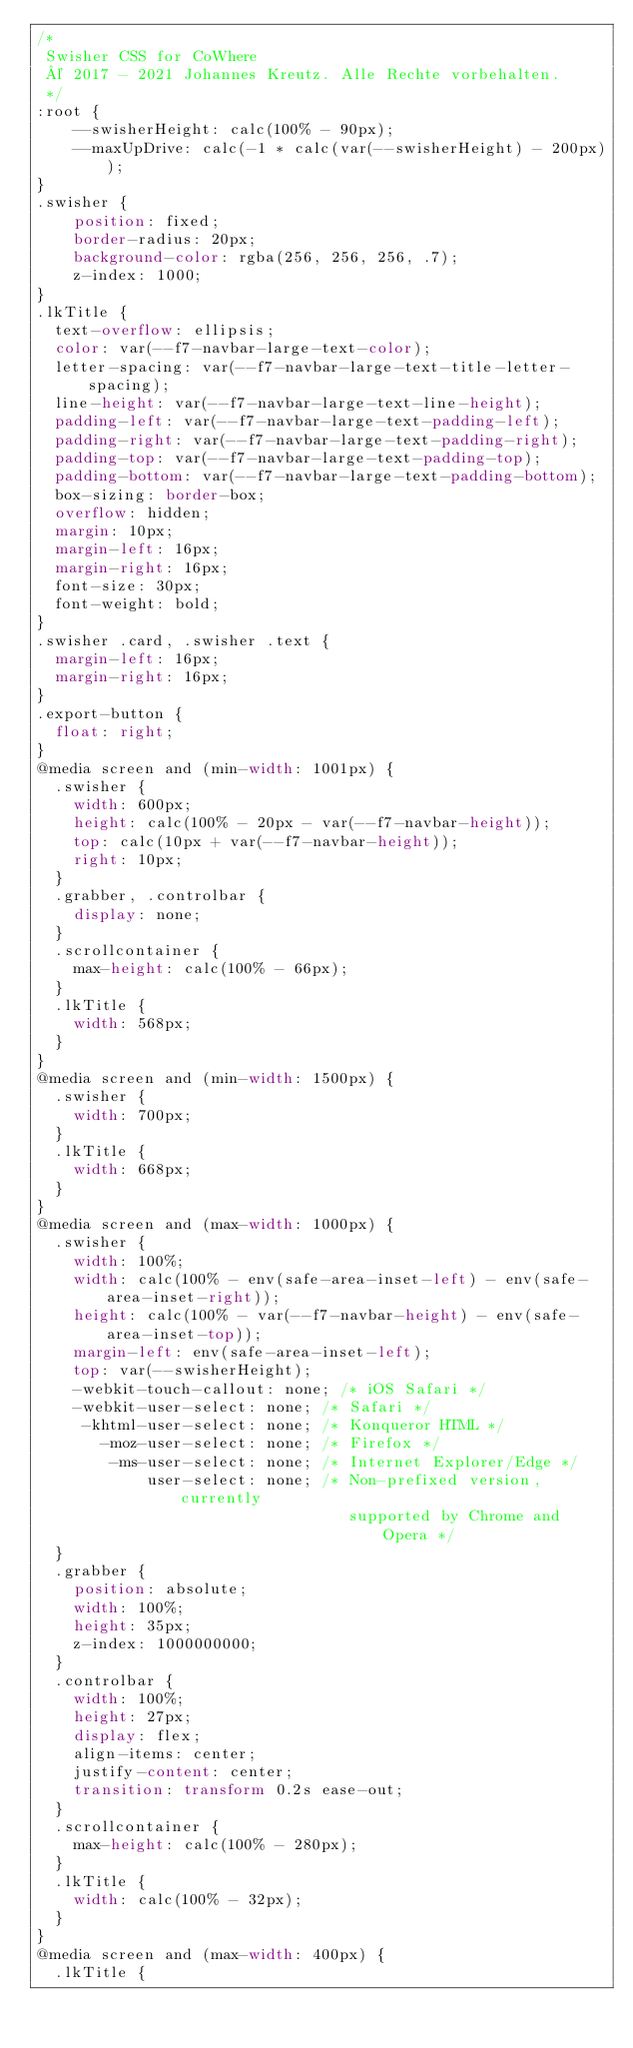Convert code to text. <code><loc_0><loc_0><loc_500><loc_500><_CSS_>/*
 Swisher CSS for CoWhere
 © 2017 - 2021 Johannes Kreutz. Alle Rechte vorbehalten.
 */
:root {
    --swisherHeight: calc(100% - 90px);
    --maxUpDrive: calc(-1 * calc(var(--swisherHeight) - 200px));
}
.swisher {
    position: fixed;
    border-radius: 20px;
    background-color: rgba(256, 256, 256, .7);
    z-index: 1000;
}
.lkTitle {
  text-overflow: ellipsis;
  color: var(--f7-navbar-large-text-color);
  letter-spacing: var(--f7-navbar-large-text-title-letter-spacing);
  line-height: var(--f7-navbar-large-text-line-height);
  padding-left: var(--f7-navbar-large-text-padding-left);
  padding-right: var(--f7-navbar-large-text-padding-right);
  padding-top: var(--f7-navbar-large-text-padding-top);
  padding-bottom: var(--f7-navbar-large-text-padding-bottom);
  box-sizing: border-box;
  overflow: hidden;
  margin: 10px;
  margin-left: 16px;
  margin-right: 16px;
  font-size: 30px;
  font-weight: bold;
}
.swisher .card, .swisher .text {
  margin-left: 16px;
  margin-right: 16px;
}
.export-button {
  float: right;
}
@media screen and (min-width: 1001px) {
  .swisher {
    width: 600px;
    height: calc(100% - 20px - var(--f7-navbar-height));
    top: calc(10px + var(--f7-navbar-height));
    right: 10px;
  }
  .grabber, .controlbar {
    display: none;
  }
  .scrollcontainer {
    max-height: calc(100% - 66px);
  }
  .lkTitle {
    width: 568px;
  }
}
@media screen and (min-width: 1500px) {
  .swisher {
    width: 700px;
  }
  .lkTitle {
    width: 668px;
  }
}
@media screen and (max-width: 1000px) {
  .swisher {
    width: 100%;
    width: calc(100% - env(safe-area-inset-left) - env(safe-area-inset-right));
    height: calc(100% - var(--f7-navbar-height) - env(safe-area-inset-top));
    margin-left: env(safe-area-inset-left);
    top: var(--swisherHeight);
    -webkit-touch-callout: none; /* iOS Safari */
    -webkit-user-select: none; /* Safari */
     -khtml-user-select: none; /* Konqueror HTML */
       -moz-user-select: none; /* Firefox */
        -ms-user-select: none; /* Internet Explorer/Edge */
            user-select: none; /* Non-prefixed version, currently
                                  supported by Chrome and Opera */
  }
  .grabber {
    position: absolute;
    width: 100%;
    height: 35px;
    z-index: 1000000000;
  }
  .controlbar {
    width: 100%;
    height: 27px;
    display: flex;
    align-items: center;
    justify-content: center;
    transition: transform 0.2s ease-out;
  }
  .scrollcontainer {
    max-height: calc(100% - 280px);
  }
  .lkTitle {
    width: calc(100% - 32px);
  }
}
@media screen and (max-width: 400px) {
  .lkTitle {</code> 